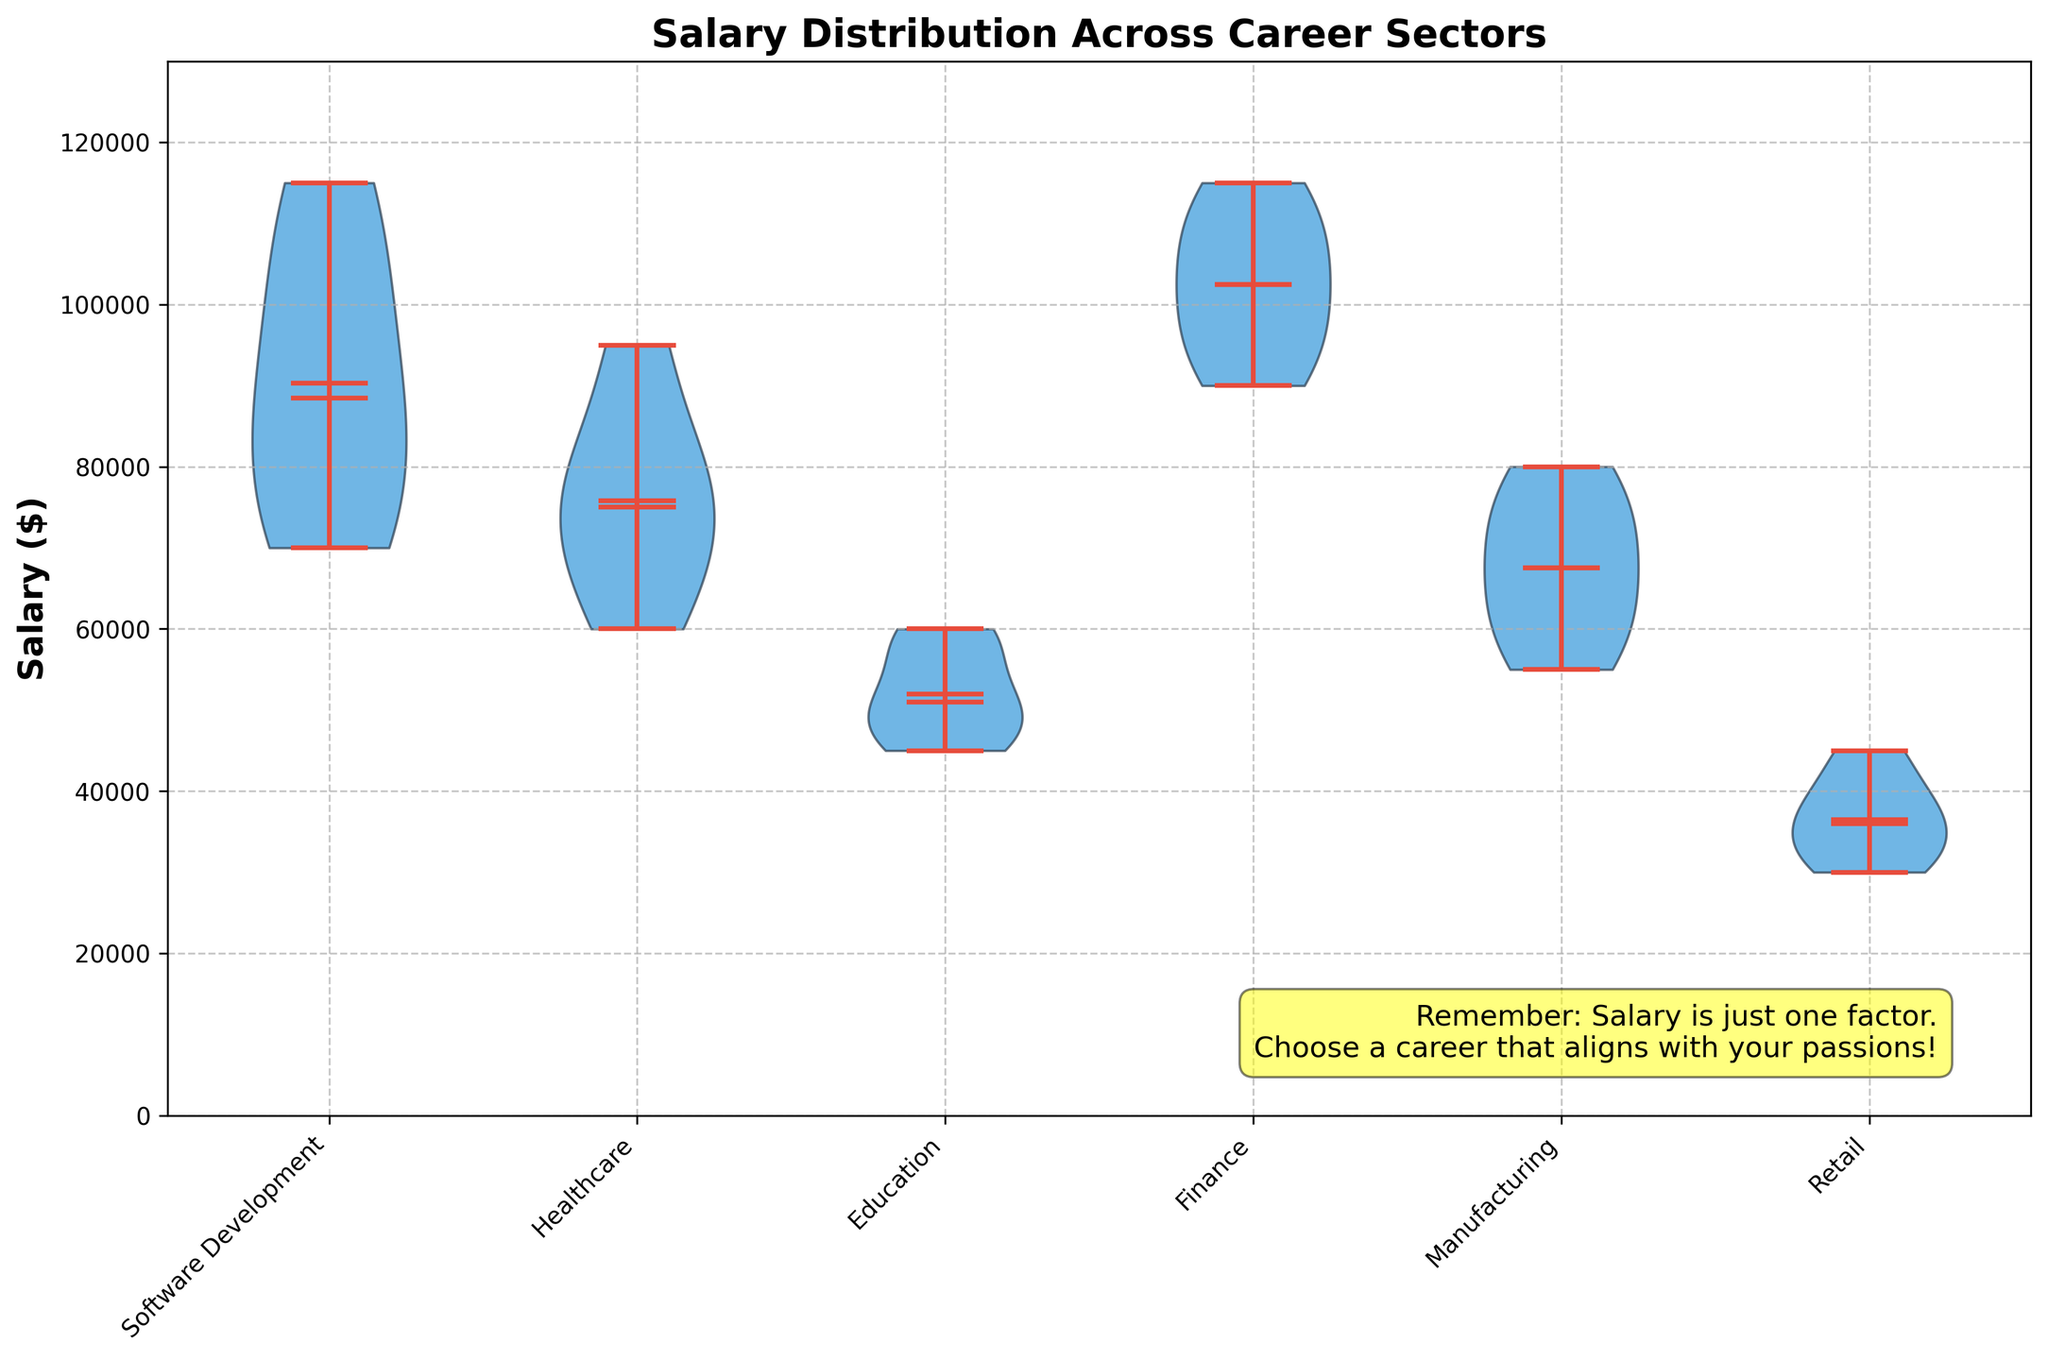What is the title of the plot? The title is located at the top of the plot and provides an overview of the data being presented. In this plot, it reads "Salary Distribution Across Career Sectors".
Answer: Salary Distribution Across Career Sectors Which career sector has the highest maximum salary? This can be determined by looking at the topmost point of each violin plot, which represents the maximum salary within each sector. The Finance sector has the highest maximum salary.
Answer: Finance How does the median salary of Healthcare compare to Manufacturing? The median is represented by a distinct line within each violin plot. On the violin plot, Healthcare's median salary is higher than Manufacturing's median salary.
Answer: Healthcare's median is higher What's the range of salaries in Software Development? The range is the difference between the maximum and minimum salaries. Based on the plot, the highest point for Software Development is 115000 and the lowest is 70000, so the range is 115000 - 70000 = 45000.
Answer: 45000 Which career sector has the smallest interquartile range (IQR)? The IQR is the range between the first quartile (25th percentile) and the third quartile (75th percentile). Observing the widths of the shaded areas within the violins, the Education sector has the smallest IQR.
Answer: Education What can you infer about the salary distribution in the Retail sector? By looking at the Retail sector's violin plot, it's narrow and has less variability with lower median and quartiles compared to other sectors; it indicates a lower and tightly clustered salary distribution.
Answer: Lower, tightly clustered salary distribution Which career sector has the most symmetrical salary distribution? Symmetry can be inferred by the shape of the violin plot; if it is evenly shaped, the distribution is symmetrical. The salary distribution in Finance appears most symmetrical.
Answer: Finance Does any career sector show a bimodal distribution? A bimodal distribution would mean two peaks within a single violin. In this case, no sector has two distinct peaks in the violins represented in the plot.
Answer: No What's the mean salary of Software Development? Means are represented by a small dot within the violin plots. By identifying this dot in Software Development, the mean salary is inferred to be around 92000.
Answer: 92000 